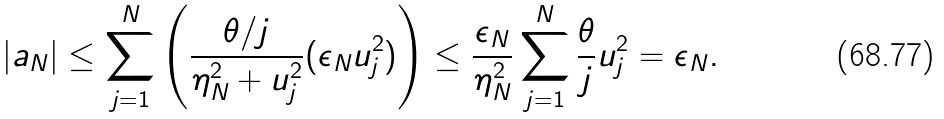<formula> <loc_0><loc_0><loc_500><loc_500>| a _ { N } | \leq \sum _ { j = 1 } ^ { N } \left ( \frac { \theta / j } { \eta _ { N } ^ { 2 } + u _ { j } ^ { 2 } } ( \epsilon _ { N } u _ { j } ^ { 2 } ) \right ) \leq \frac { \epsilon _ { N } } { \eta _ { N } ^ { 2 } } \sum _ { j = 1 } ^ { N } \frac { \theta } { j } u _ { j } ^ { 2 } = \epsilon _ { N } .</formula> 